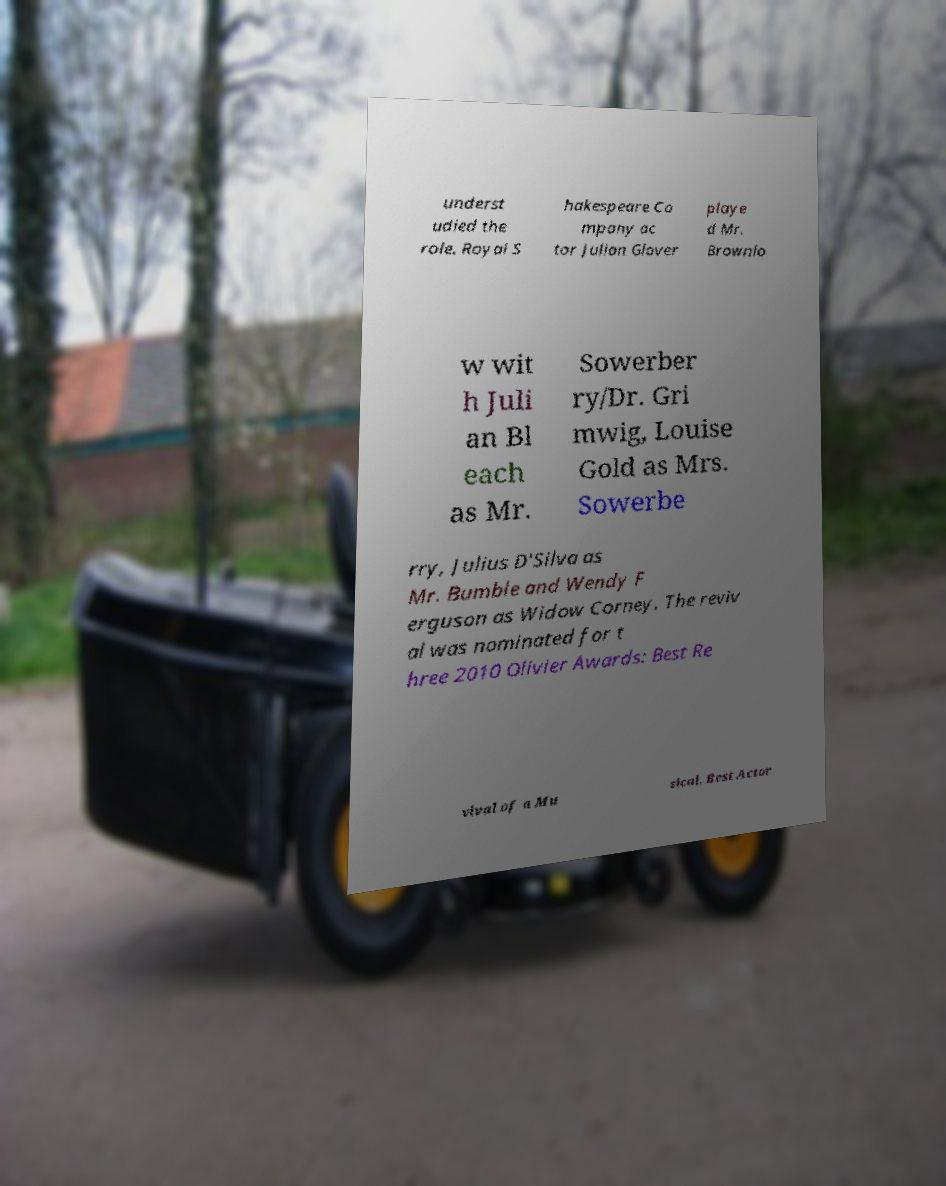Could you extract and type out the text from this image? underst udied the role. Royal S hakespeare Co mpany ac tor Julian Glover playe d Mr. Brownlo w wit h Juli an Bl each as Mr. Sowerber ry/Dr. Gri mwig, Louise Gold as Mrs. Sowerbe rry, Julius D'Silva as Mr. Bumble and Wendy F erguson as Widow Corney. The reviv al was nominated for t hree 2010 Olivier Awards: Best Re vival of a Mu sical, Best Actor 